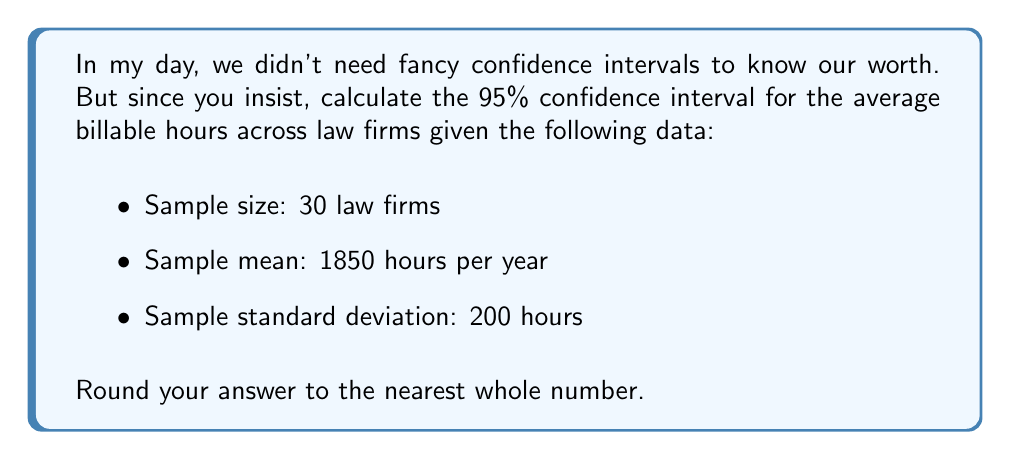Give your solution to this math problem. To calculate the confidence interval, we'll use the formula:

$$ \text{CI} = \bar{x} \pm t_{\alpha/2} \cdot \frac{s}{\sqrt{n}} $$

Where:
$\bar{x}$ is the sample mean
$t_{\alpha/2}$ is the t-value for a 95% confidence level with n-1 degrees of freedom
$s$ is the sample standard deviation
$n$ is the sample size

Steps:
1) We have $\bar{x} = 1850$, $s = 200$, and $n = 30$

2) Degrees of freedom = $n - 1 = 29$

3) For a 95% confidence level with 29 degrees of freedom, $t_{\alpha/2} \approx 2.045$ (from t-distribution table)

4) Calculate the margin of error:
   $$ \text{ME} = t_{\alpha/2} \cdot \frac{s}{\sqrt{n}} = 2.045 \cdot \frac{200}{\sqrt{30}} \approx 74.67 $$

5) Calculate the confidence interval:
   $$ \text{CI} = 1850 \pm 74.67 $$

6) Round to the nearest whole number:
   $$ \text{CI} = (1775, 1925) $$
Answer: (1775, 1925) 